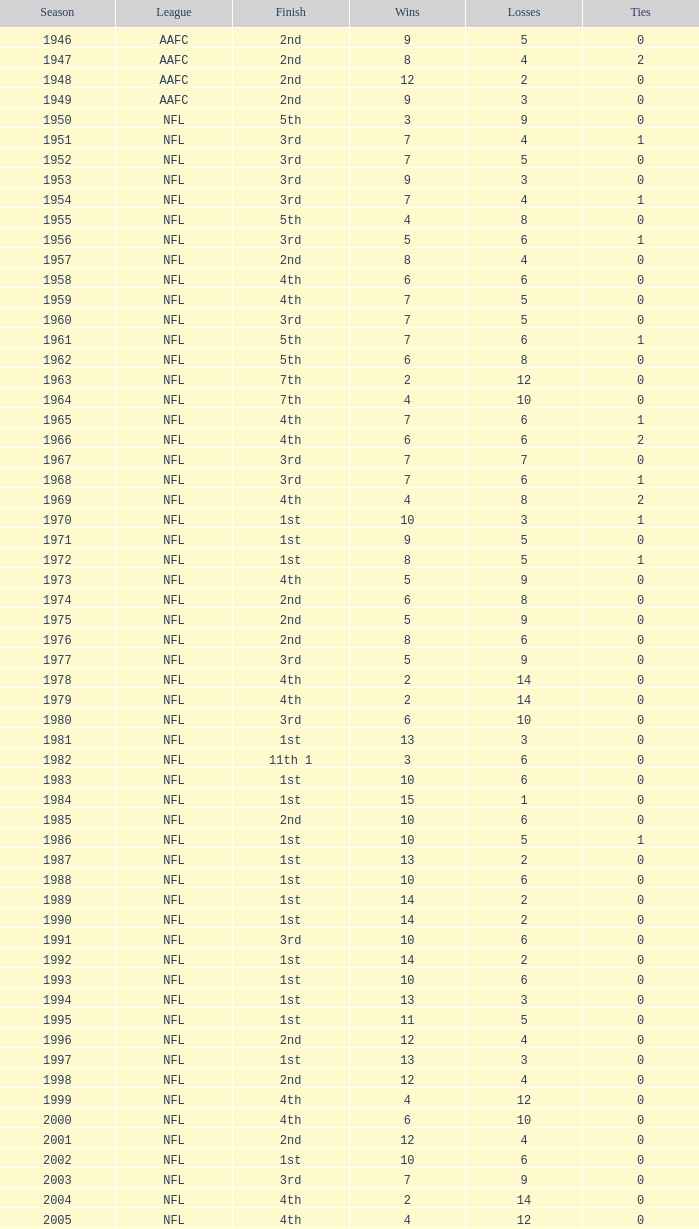What is the minimum number of ties in the nfl, with fewer than 2 losses and under 15 victories? None. 